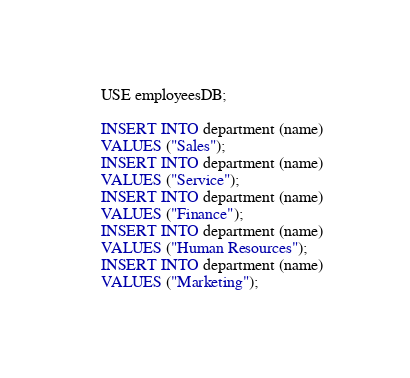<code> <loc_0><loc_0><loc_500><loc_500><_SQL_>USE employeesDB;

INSERT INTO department (name)
VALUES ("Sales");
INSERT INTO department (name)
VALUES ("Service");
INSERT INTO department (name)
VALUES ("Finance");
INSERT INTO department (name)
VALUES ("Human Resources");
INSERT INTO department (name)
VALUES ("Marketing");
</code> 